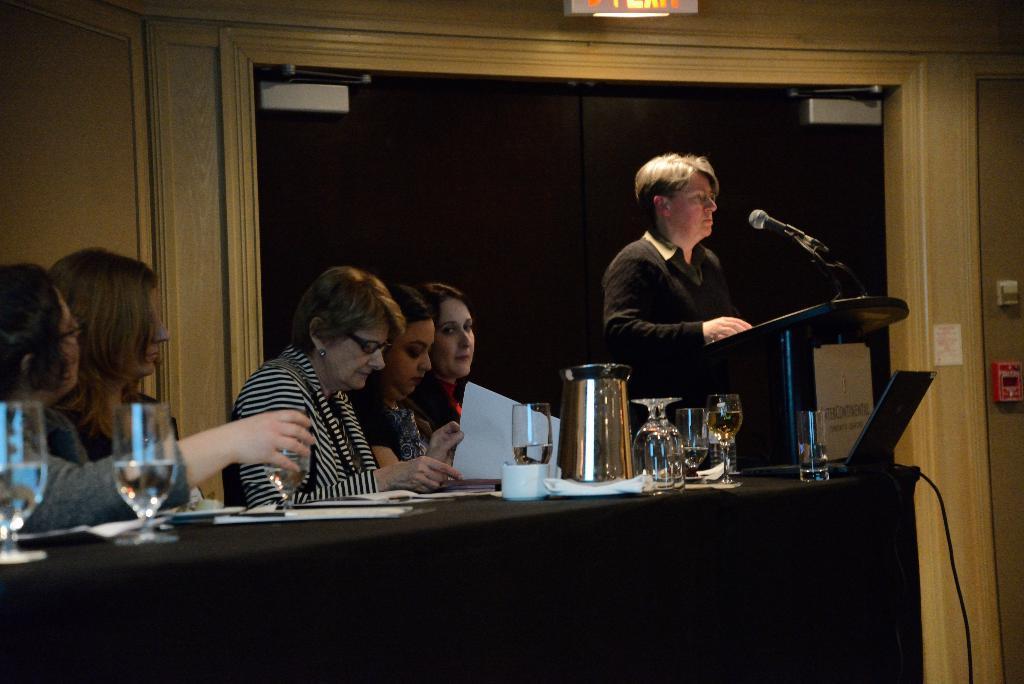In one or two sentences, can you explain what this image depicts? This persons are sitting on a chair. In-front of this person there is a table, on a table there is a jar, glasses, cup and papers. This woman is holding a paper. This person is standing. In-front of this person there is a podium with mic. 